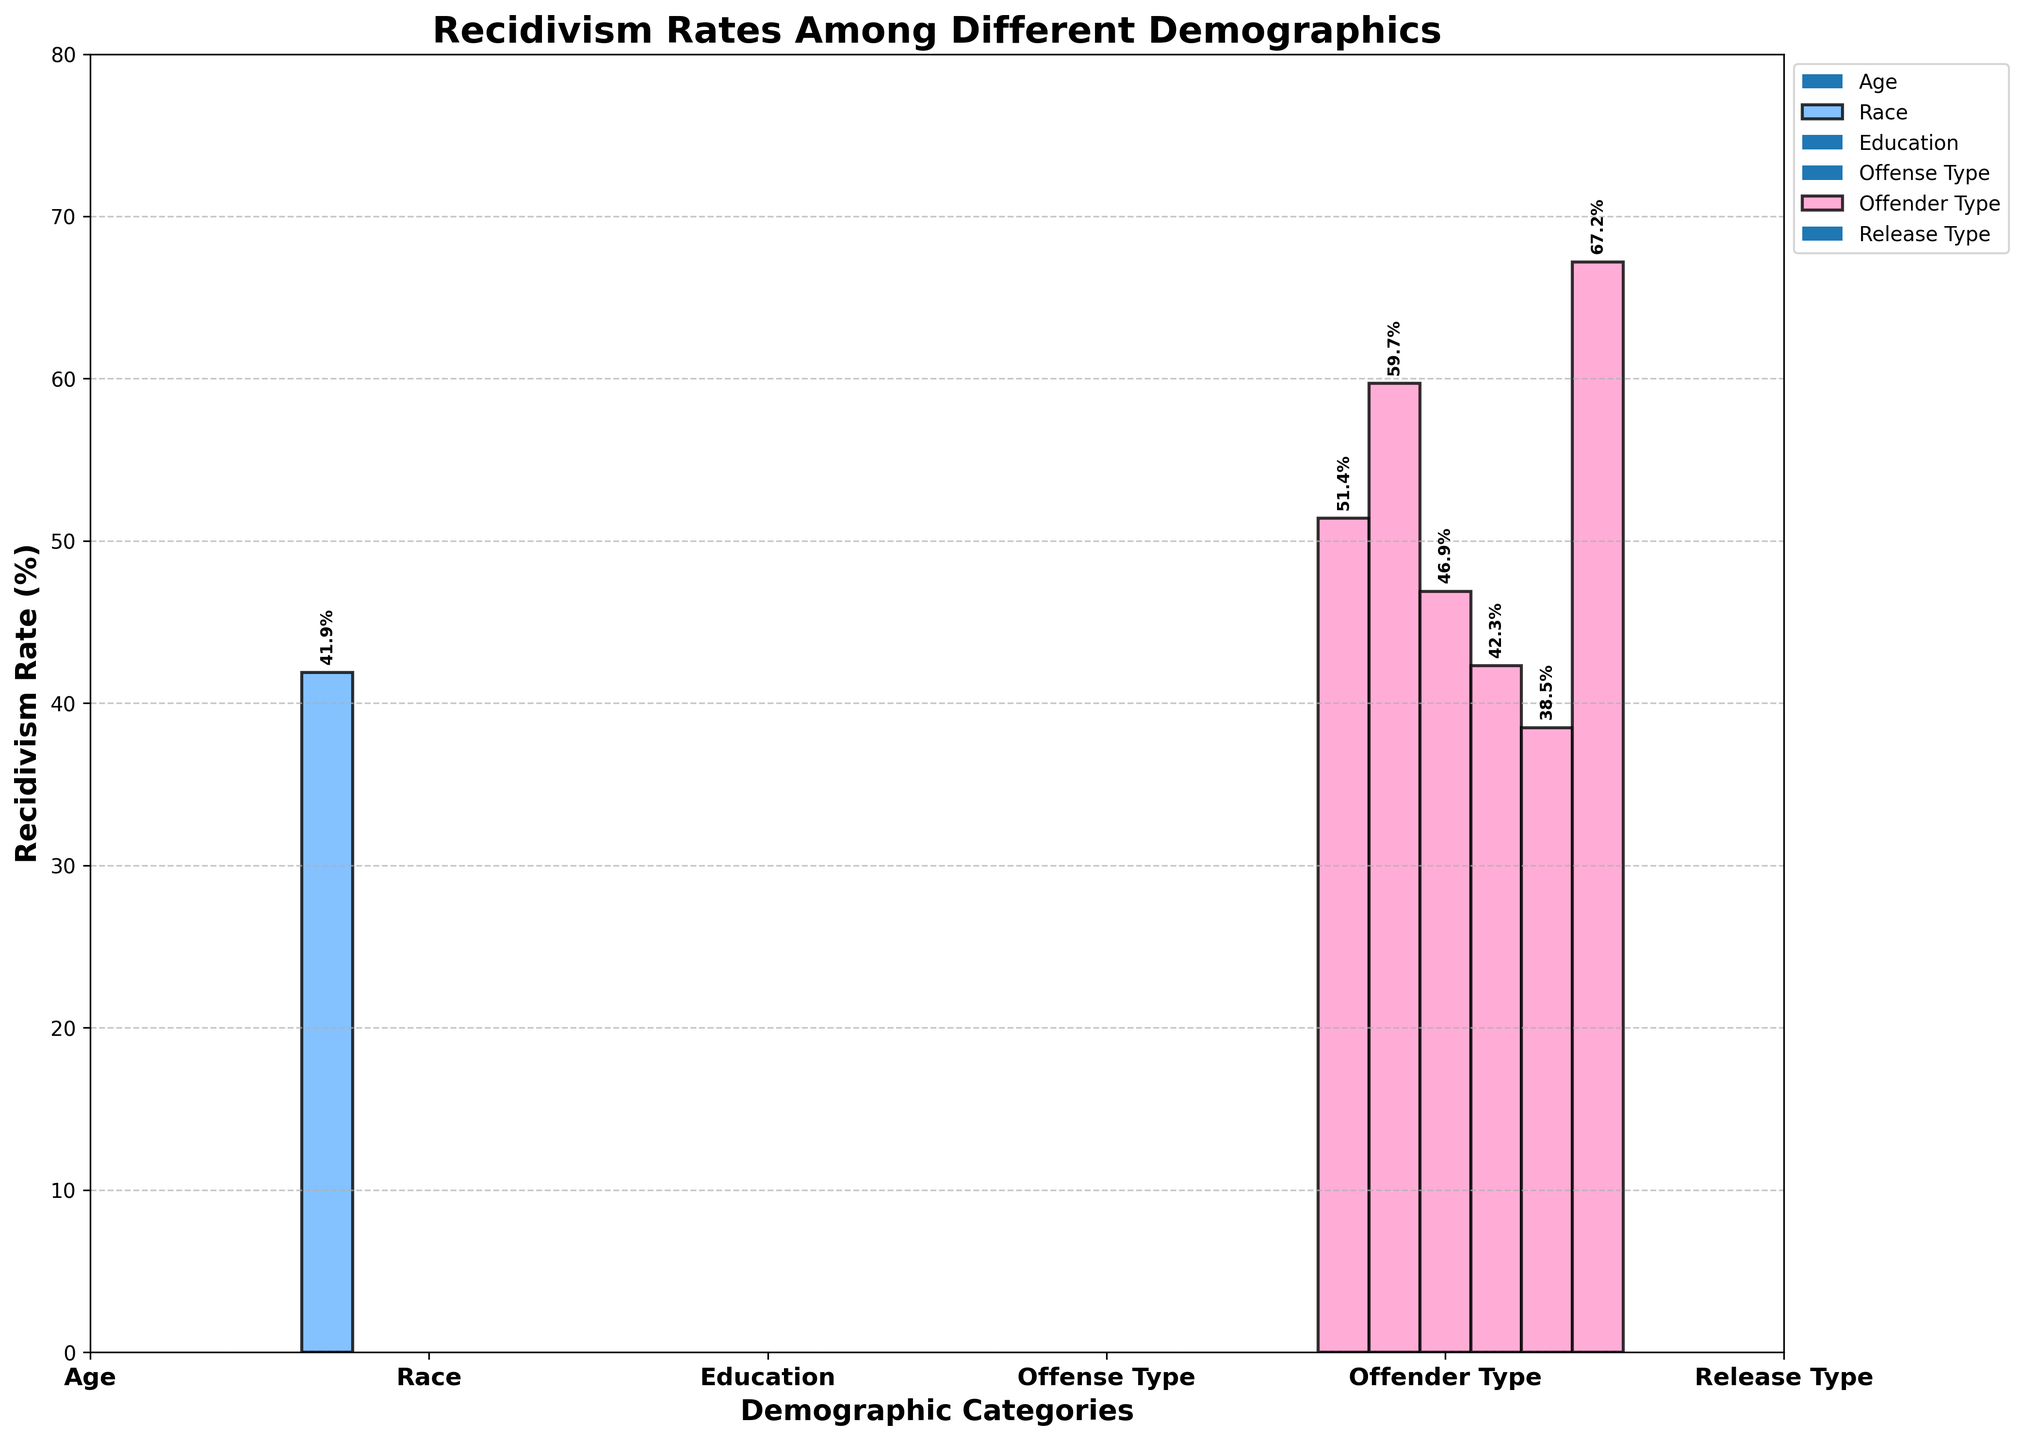What age group has the highest recidivism rate? The bar representing the age group 18-24 years old is the tallest among all age groups, indicating the highest recidivism rate.
Answer: 18-24 years old What is the difference in recidivism rates between violent offenders and property offenders? The recidivism rate for violent offenders is 51.4%, and for property offenders, it is 59.7%. Subtracting these gives the difference: 59.7% - 51.4%.
Answer: 8.3% Which group has a lower recidivism rate: those with a high school diploma or those with some college education? The bar for individuals with some college education is shorter compared to the bar for those with a high school diploma, indicating a lower recidivism rate for those with some college education.
Answer: Some college What demographic has the lowest recidivism rate? Among all demographics displayed, the bar for those with a bachelor's degree or higher is the shortest, indicating the lowest recidivism rate at 27.6%.
Answer: Bachelor's degree or higher Compare the recidivism rates of first-time offenders and repeat offenders. What do you observe? The recidivism rate for first-time offenders is 38.5%, while for repeat offenders, it is 67.2%. The rate for repeat offenders is significantly higher.
Answer: Repeat offenders have a significantly higher recidivism rate What is the average recidivism rate across all educational levels? The recidivism rates are 62.5%, 53.2%, 41.8%, and 27.6%. Summing these (62.5 + 53.2 + 41.8 + 27.6) equals 185.1. Dividing by the number of groups (4) gives the average: 185.1 / 4.
Answer: 46.275% How much higher is the recidivism rate for individuals released without supervision compared to those released with supervision? The recidivism rate for individuals released without supervision is 58.9%, and for those released with supervision, it is 44.7%. The difference is 58.9% - 44.7%.
Answer: 14.2% Does the recidivism rate for Black individuals exceed that for Hispanic individuals? The recidivism rate for Black individuals is 54.3%, and for Hispanic individuals, it is 50.7%. Since 54.3% > 50.7%, the recidivism rate for Black individuals is higher.
Answer: Yes Which offense type has the highest recidivism rate? The bar for property offenders is the tallest among the offense types, indicating the highest recidivism rate at 59.7%.
Answer: Property offenders 